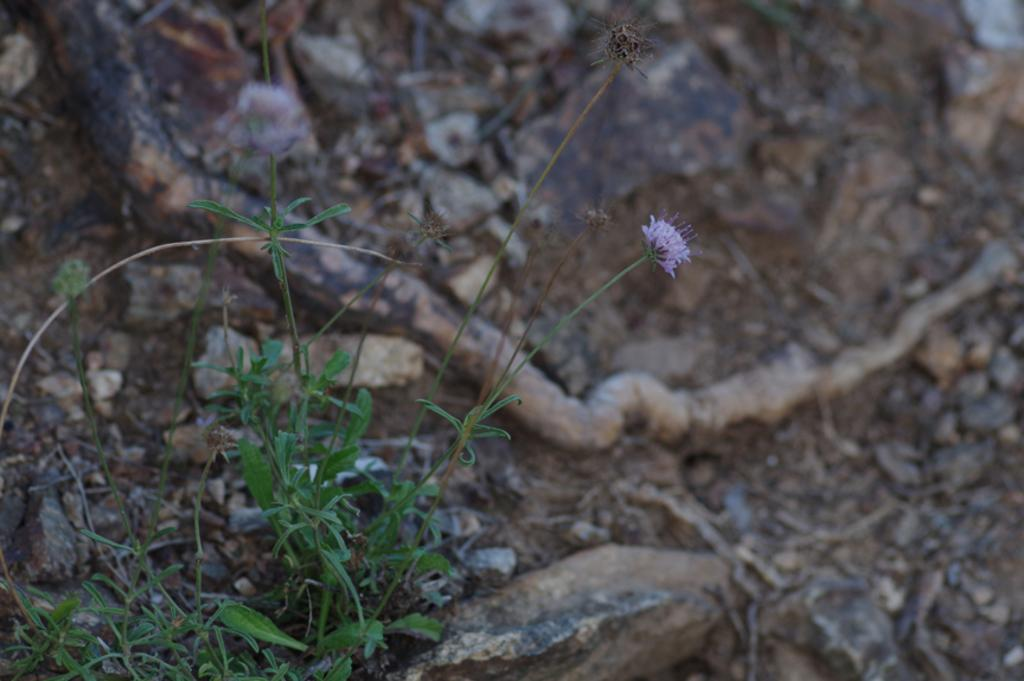What type of living organisms can be seen in the image? Plants and a flower are visible in the image. What part of the natural environment is visible in the image? The ground is visible in the image. How many cherries are hanging from the ship in the image? There is no ship or cherries present in the image. 